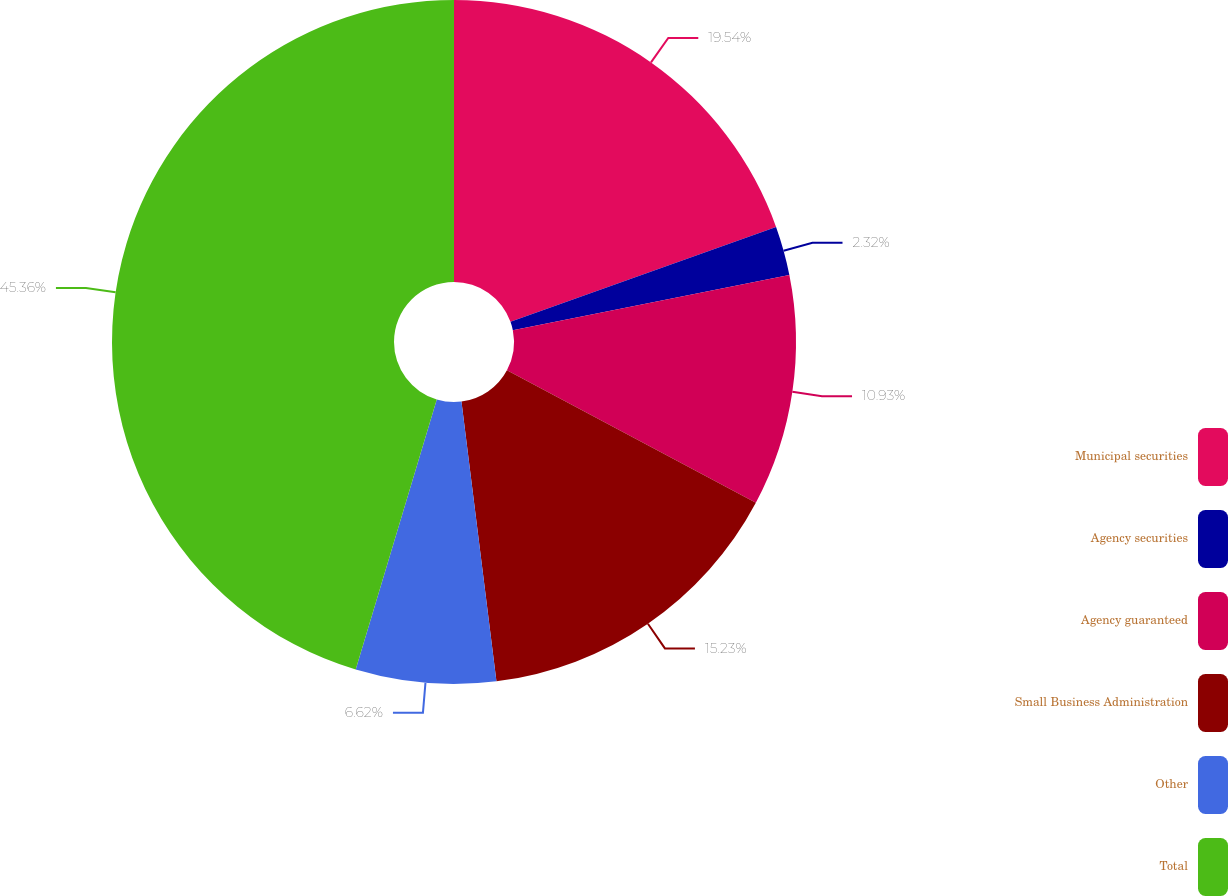Convert chart. <chart><loc_0><loc_0><loc_500><loc_500><pie_chart><fcel>Municipal securities<fcel>Agency securities<fcel>Agency guaranteed<fcel>Small Business Administration<fcel>Other<fcel>Total<nl><fcel>19.54%<fcel>2.32%<fcel>10.93%<fcel>15.23%<fcel>6.62%<fcel>45.36%<nl></chart> 